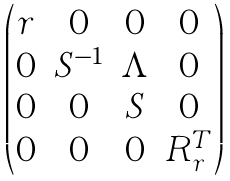<formula> <loc_0><loc_0><loc_500><loc_500>\begin{pmatrix} r & 0 & 0 & 0 \\ 0 & S ^ { - 1 } & \Lambda & 0 \\ 0 & 0 & S & 0 \\ 0 & 0 & 0 & R ^ { T } _ { r } \end{pmatrix}</formula> 